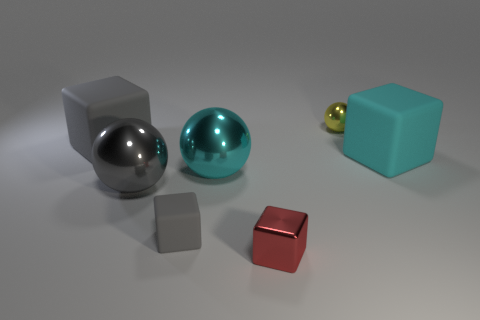Is there a cyan shiny object that has the same size as the cyan matte block?
Your answer should be very brief. Yes. There is a cyan thing left of the tiny red metal block; does it have the same size as the cube on the right side of the yellow metal object?
Your answer should be very brief. Yes. There is a cyan thing in front of the large cube right of the yellow ball; what is its shape?
Keep it short and to the point. Sphere. There is a large gray ball; what number of cubes are on the right side of it?
Offer a very short reply. 3. There is a tiny sphere that is made of the same material as the large cyan sphere; what color is it?
Your response must be concise. Yellow. Do the yellow ball and the metal thing in front of the small rubber block have the same size?
Provide a short and direct response. Yes. What is the size of the cyan thing that is behind the cyan object to the left of the big rubber object on the right side of the tiny red metal block?
Provide a succinct answer. Large. How many shiny things are either large gray spheres or red blocks?
Make the answer very short. 2. There is a big matte block to the right of the big cyan sphere; what color is it?
Offer a terse response. Cyan. What is the shape of the cyan shiny thing that is the same size as the cyan cube?
Offer a terse response. Sphere. 